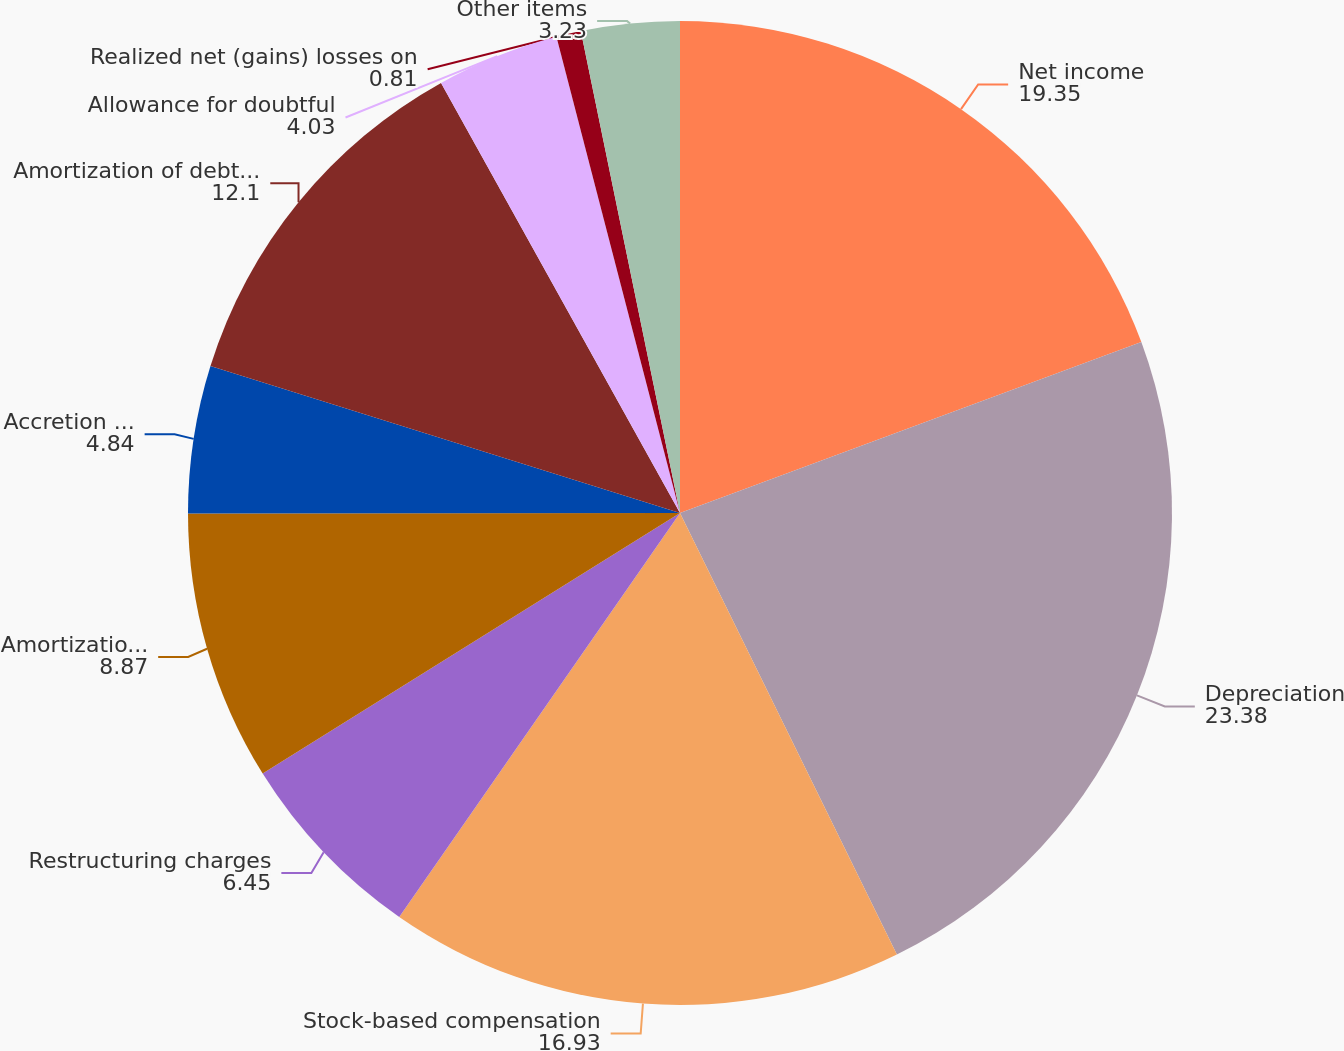Convert chart to OTSL. <chart><loc_0><loc_0><loc_500><loc_500><pie_chart><fcel>Net income<fcel>Depreciation<fcel>Stock-based compensation<fcel>Restructuring charges<fcel>Amortization of intangible<fcel>Accretion of asset retirement<fcel>Amortization of debt issuance<fcel>Allowance for doubtful<fcel>Realized net (gains) losses on<fcel>Other items<nl><fcel>19.35%<fcel>23.38%<fcel>16.93%<fcel>6.45%<fcel>8.87%<fcel>4.84%<fcel>12.1%<fcel>4.03%<fcel>0.81%<fcel>3.23%<nl></chart> 